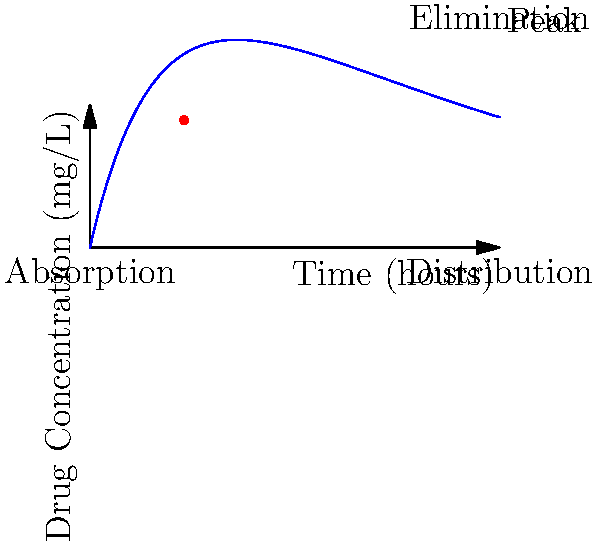The graph shows the pharmacokinetics of a drug over time. At which phase of the drug's journey in the body does the peak concentration occur, and what does this indicate about the drug's absorption and elimination rates at this point? To answer this question, let's analyze the graph step-by-step:

1. The graph shows three distinct phases of drug pharmacokinetics:
   a) Absorption: The initial rise in concentration
   b) Distribution: The period around the peak
   c) Elimination: The gradual decline in concentration

2. The peak concentration occurs at the highest point on the curve, which is at the transition between the absorption and distribution phases.

3. At the peak:
   a) The absorption rate equals the elimination rate
   b) The drug concentration in the blood is at its maximum

4. This equilibrium indicates that:
   a) The rate of drug entering the bloodstream (absorption) has reached its maximum
   b) The rate of drug leaving the bloodstream (distribution + elimination) is beginning to match the absorption rate

5. After the peak:
   a) The elimination rate becomes greater than the absorption rate
   b) The drug concentration starts to decrease

6. The location of the peak provides information about:
   a) How quickly the drug is absorbed (steepness of the initial rise)
   b) How long the drug remains in the body (gradual decline after the peak)

Therefore, the peak concentration occurs at the end of the absorption phase and the beginning of the distribution phase. It indicates the point where the absorption rate equals the elimination rate, marking the transition from net drug accumulation to net drug elimination in the body.
Answer: The peak occurs at the transition between absorption and distribution phases, indicating equal absorption and elimination rates. 